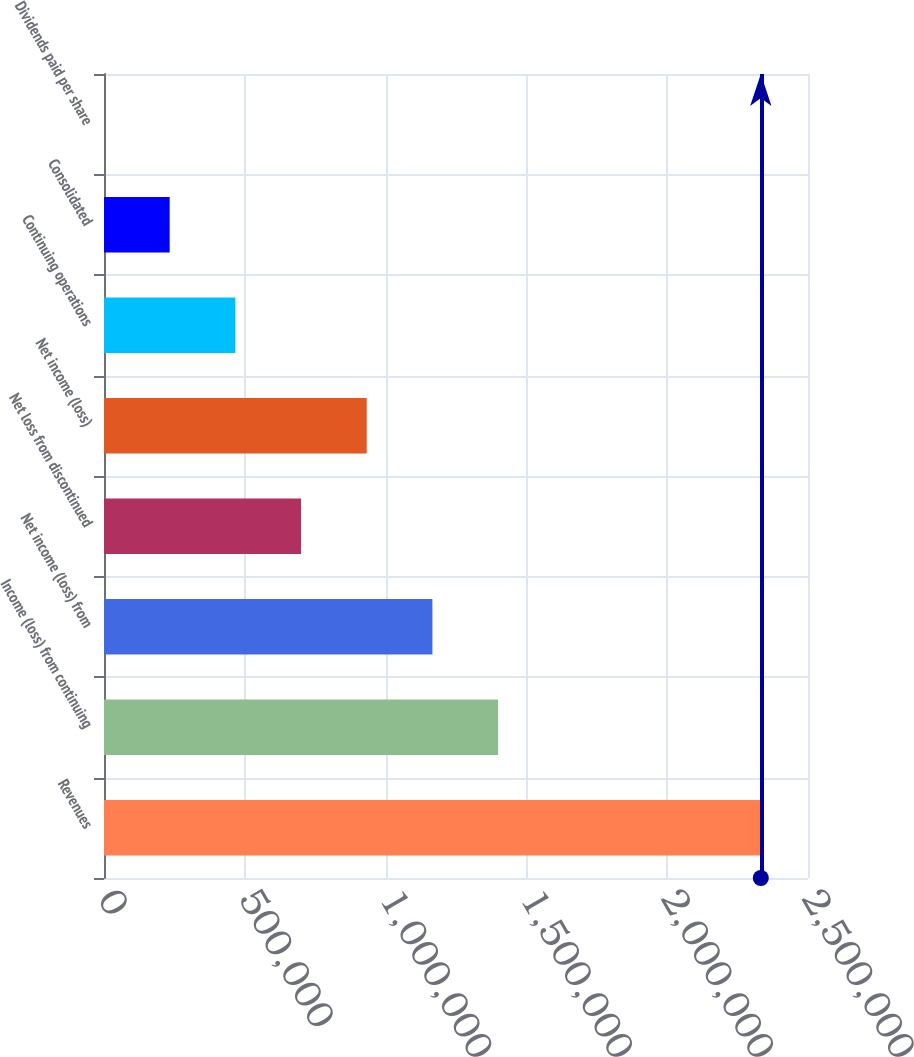Convert chart. <chart><loc_0><loc_0><loc_500><loc_500><bar_chart><fcel>Revenues<fcel>Income (loss) from continuing<fcel>Net income (loss) from<fcel>Net loss from discontinued<fcel>Net income (loss)<fcel>Continuing operations<fcel>Consolidated<fcel>Dividends paid per share<nl><fcel>2.33244e+06<fcel>1.39947e+06<fcel>1.16622e+06<fcel>699733<fcel>932977<fcel>466489<fcel>233245<fcel>0.25<nl></chart> 